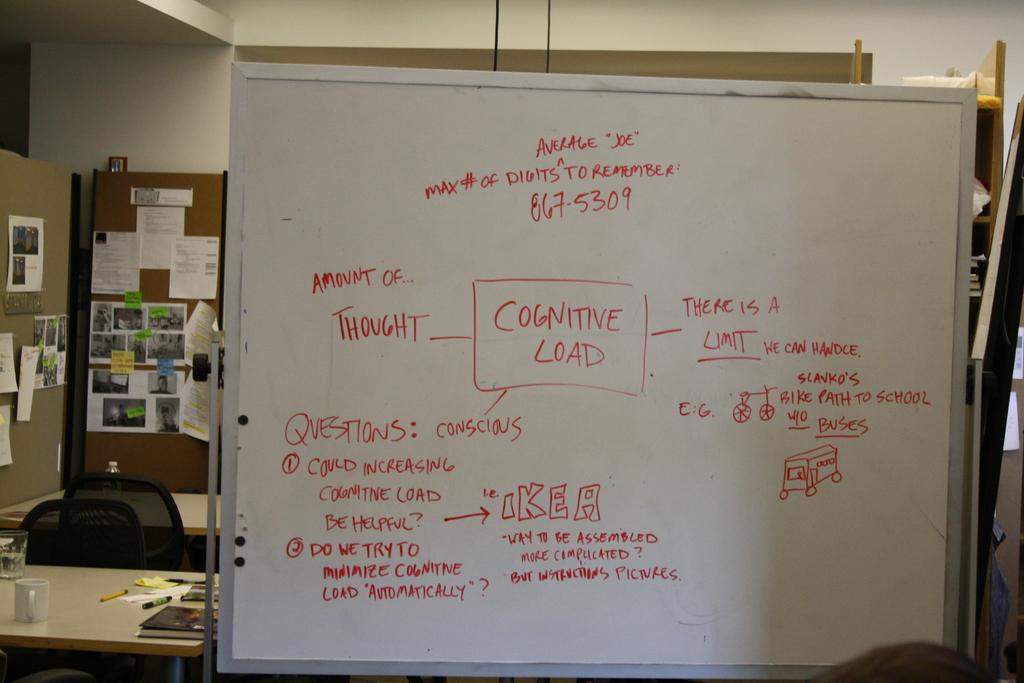Provide a one-sentence caption for the provided image. A white board full of red writing with the word cognitive load in a square. 